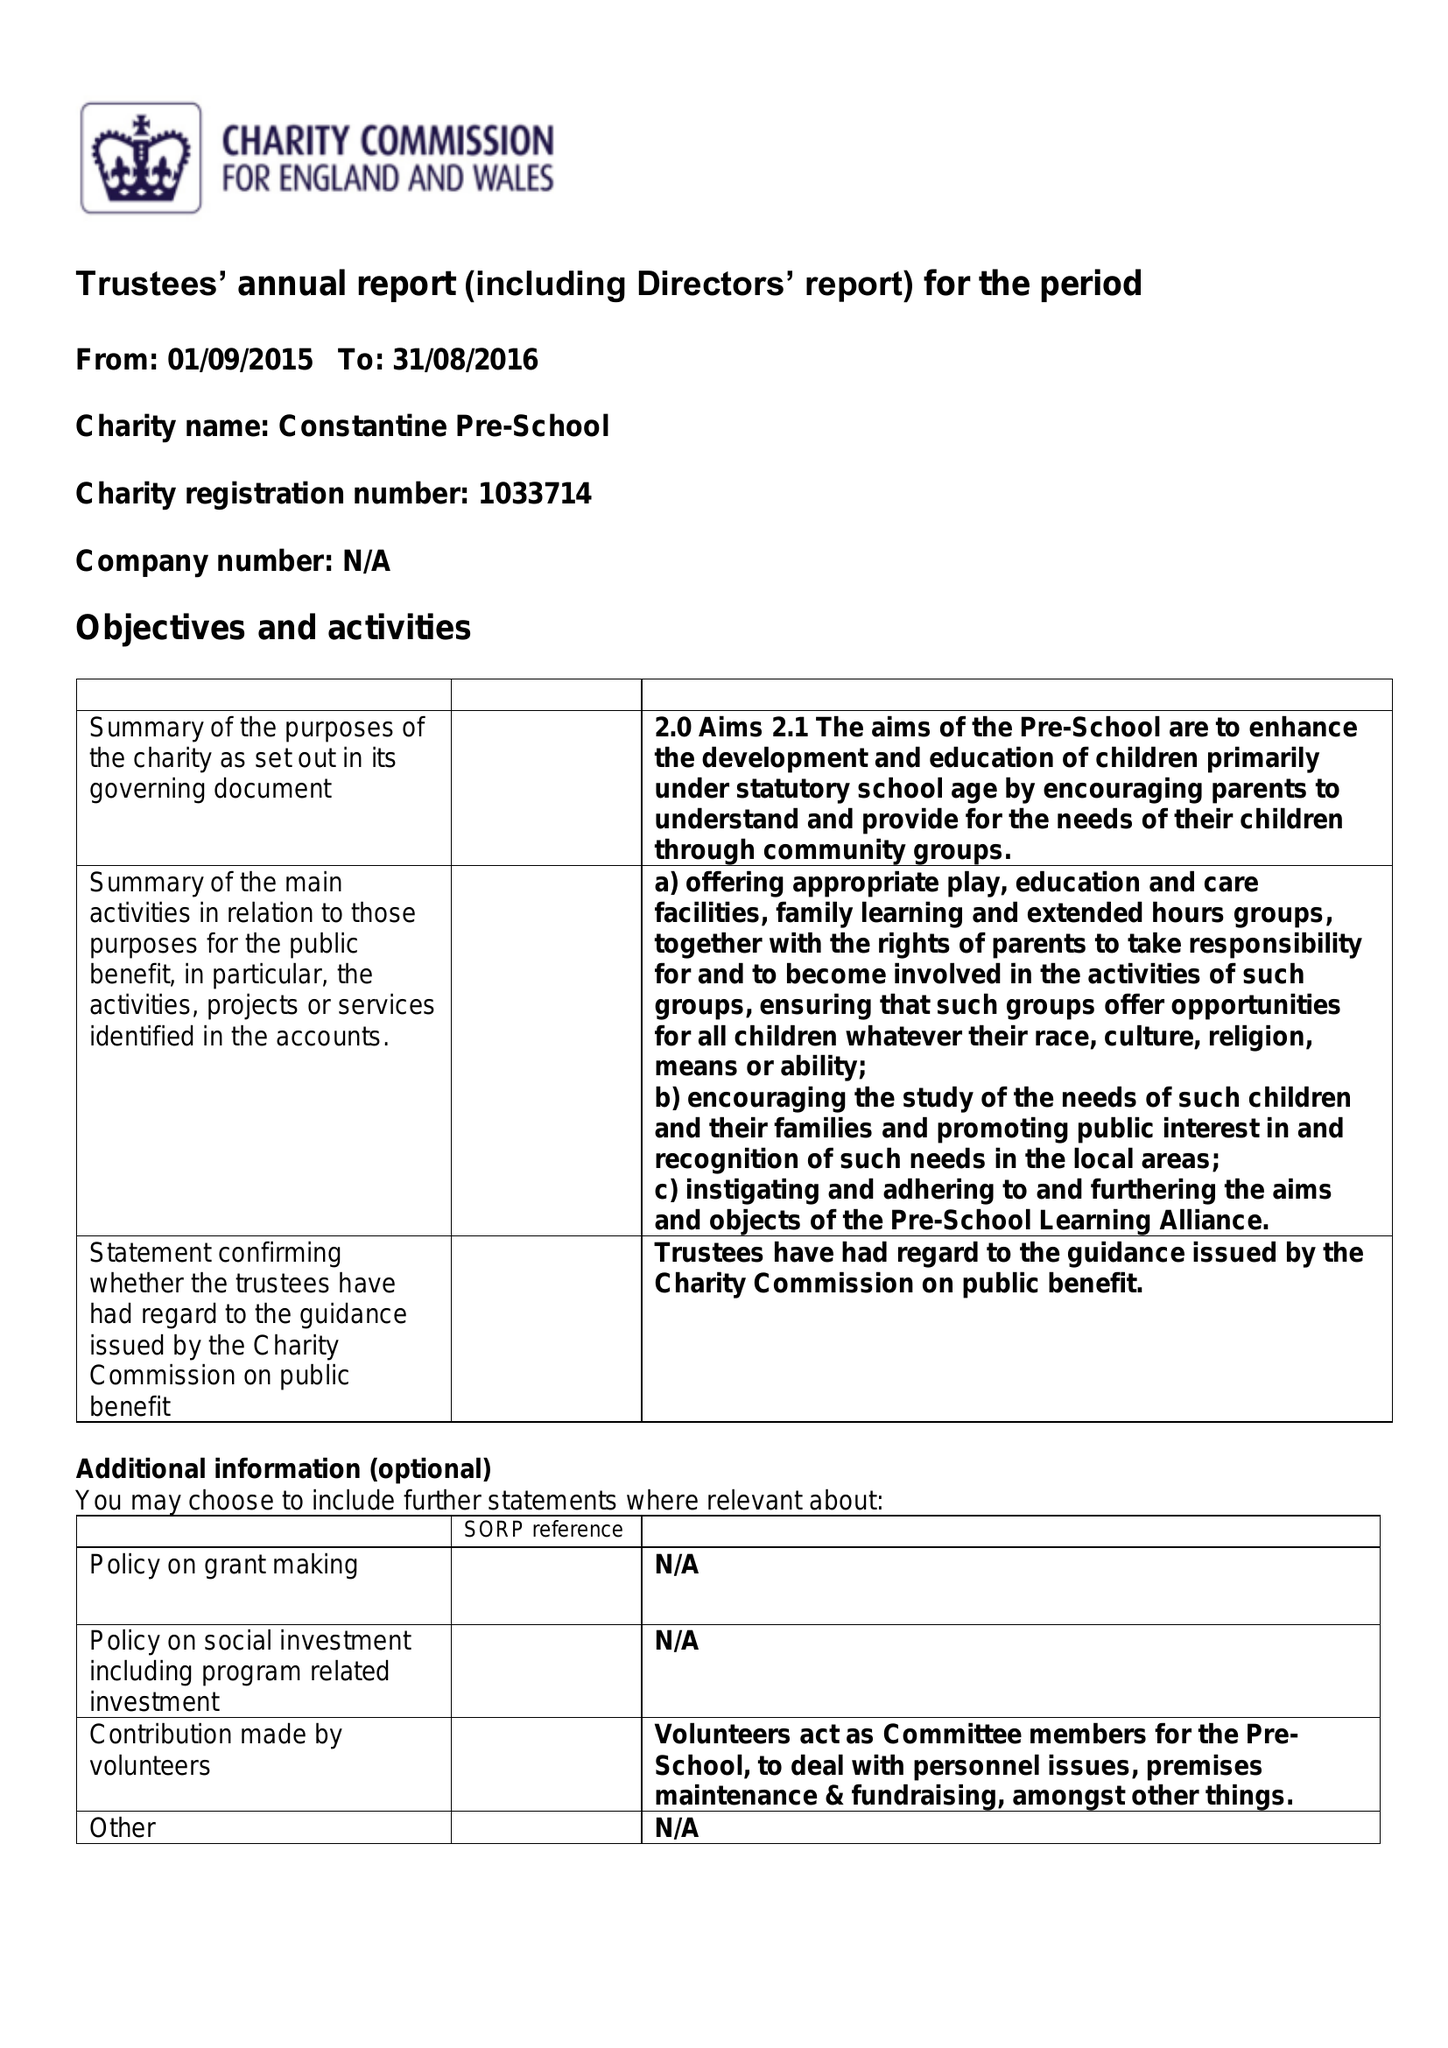What is the value for the address__street_line?
Answer the question using a single word or phrase. TREBARVAH ROAD 